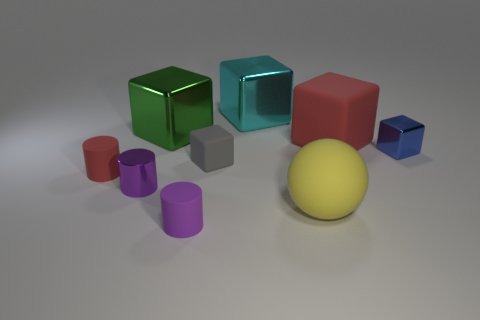What is the size of the object in front of the big matte object in front of the large red block?
Provide a short and direct response. Small. Are there any other things that have the same material as the cyan thing?
Your answer should be very brief. Yes. Are there more large cyan shiny things than tiny cyan things?
Offer a terse response. Yes. There is a large object that is on the left side of the tiny gray block; does it have the same color as the large thing that is in front of the big red cube?
Your response must be concise. No. There is a red object that is on the left side of the cyan thing; is there a big sphere behind it?
Offer a very short reply. No. Are there fewer small rubber blocks that are behind the big cyan block than yellow matte things that are behind the small purple shiny cylinder?
Offer a very short reply. No. Is the material of the large thing in front of the gray matte block the same as the big object on the left side of the tiny gray matte object?
Give a very brief answer. No. How many big objects are green rubber spheres or gray things?
Make the answer very short. 0. There is a purple thing that is made of the same material as the cyan cube; what is its shape?
Ensure brevity in your answer.  Cylinder. Are there fewer tiny gray rubber things that are in front of the gray matte block than tiny green metallic cubes?
Offer a very short reply. No. 